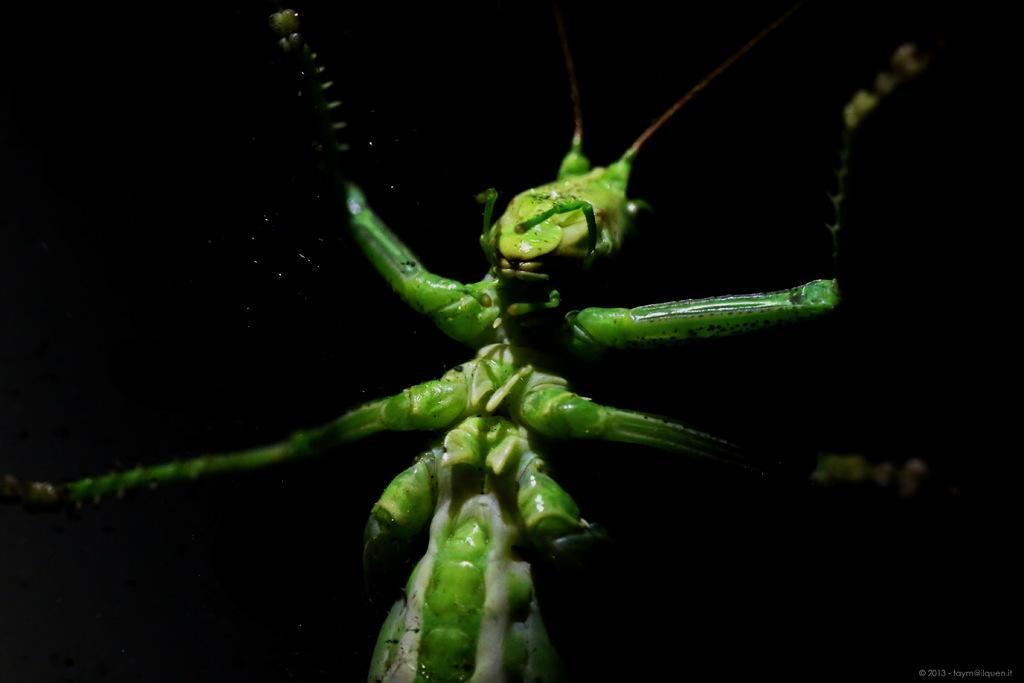Could you give a brief overview of what you see in this image? In this image there is an insect, at the bottom of the image there is some text. 